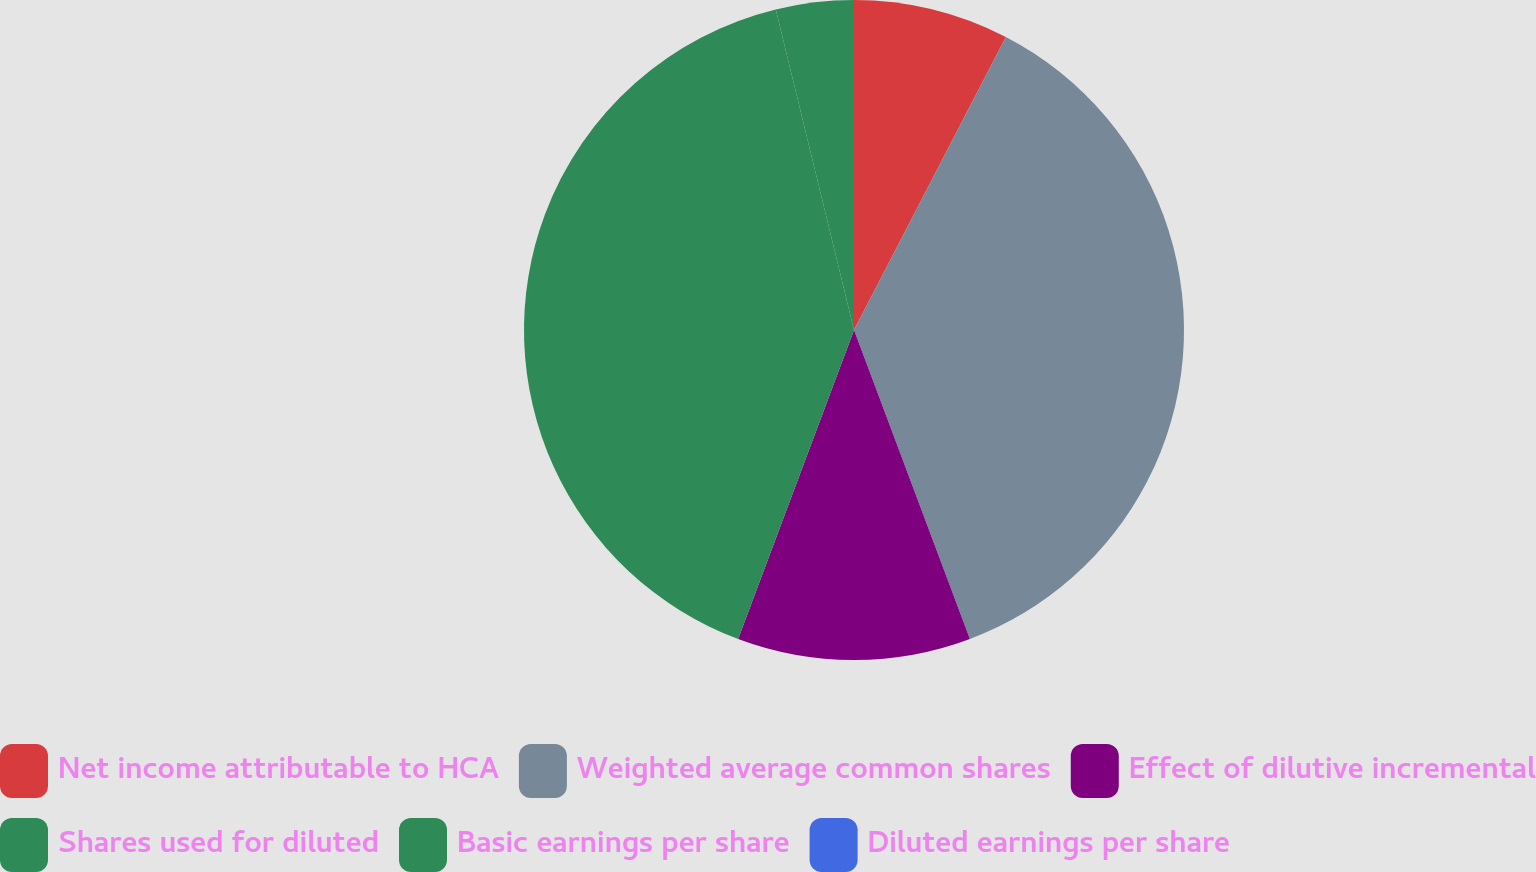<chart> <loc_0><loc_0><loc_500><loc_500><pie_chart><fcel>Net income attributable to HCA<fcel>Weighted average common shares<fcel>Effect of dilutive incremental<fcel>Shares used for diluted<fcel>Basic earnings per share<fcel>Diluted earnings per share<nl><fcel>7.61%<fcel>36.68%<fcel>11.42%<fcel>40.48%<fcel>3.81%<fcel>0.0%<nl></chart> 